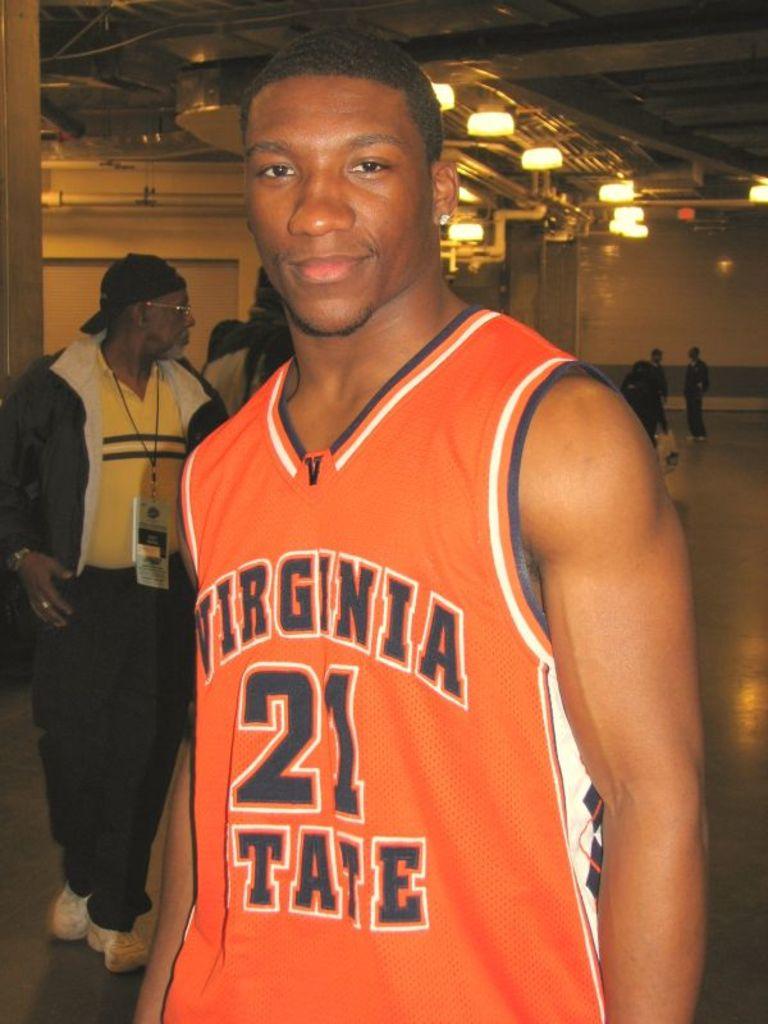What state does this player play in?
Your answer should be compact. Virginia. What is this player's number?
Your response must be concise. 21. 